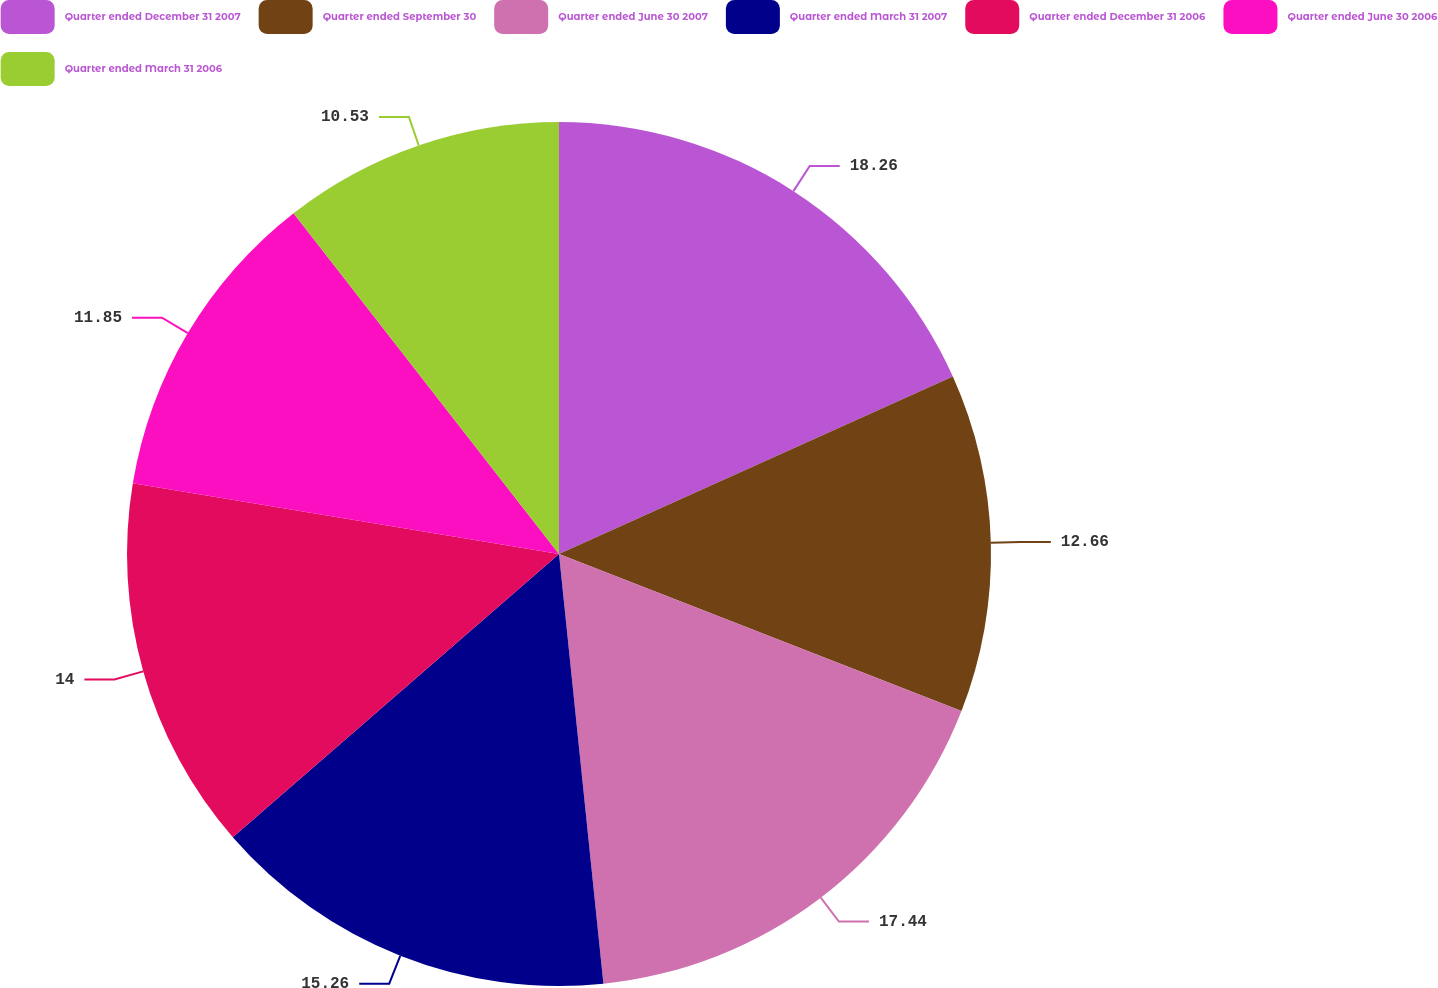Convert chart to OTSL. <chart><loc_0><loc_0><loc_500><loc_500><pie_chart><fcel>Quarter ended December 31 2007<fcel>Quarter ended September 30<fcel>Quarter ended June 30 2007<fcel>Quarter ended March 31 2007<fcel>Quarter ended December 31 2006<fcel>Quarter ended June 30 2006<fcel>Quarter ended March 31 2006<nl><fcel>18.26%<fcel>12.66%<fcel>17.44%<fcel>15.26%<fcel>14.0%<fcel>11.85%<fcel>10.53%<nl></chart> 